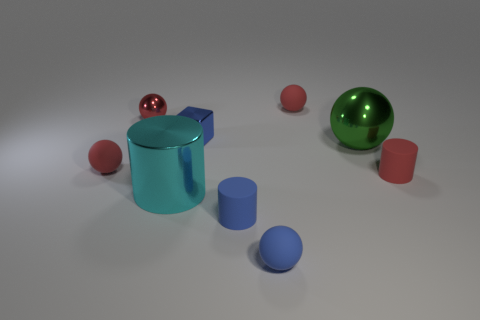There is a matte ball that is in front of the cylinder that is right of the metallic thing right of the tiny cube; how big is it?
Offer a terse response. Small. Is the shape of the green shiny thing the same as the tiny red shiny object?
Your answer should be compact. Yes. There is a rubber sphere that is behind the large cyan metallic cylinder and to the right of the tiny blue metal cube; what size is it?
Provide a succinct answer. Small. There is a green object that is the same shape as the small red metallic object; what is its material?
Your answer should be compact. Metal. The small blue cylinder that is in front of the blue thing behind the large cyan cylinder is made of what material?
Offer a terse response. Rubber. There is a red metallic thing; does it have the same shape as the cyan metallic thing that is on the left side of the big sphere?
Provide a short and direct response. No. What number of matte things are either blue blocks or cylinders?
Your answer should be very brief. 2. What is the color of the small matte ball that is to the left of the metal sphere left of the tiny red rubber object behind the blue block?
Provide a succinct answer. Red. What number of other things are there of the same material as the cyan object
Provide a short and direct response. 3. There is a small matte thing left of the small blue block; does it have the same shape as the green shiny object?
Give a very brief answer. Yes. 